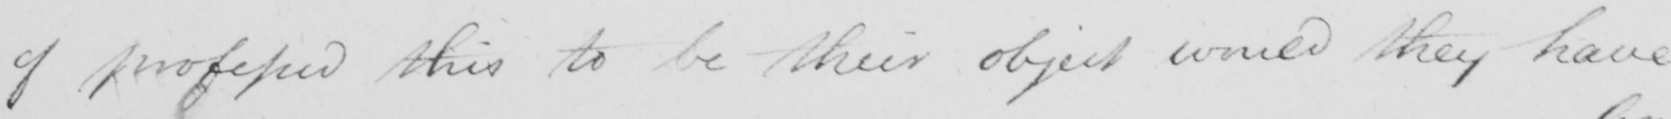What is written in this line of handwriting? of professed this to be their object would they have 